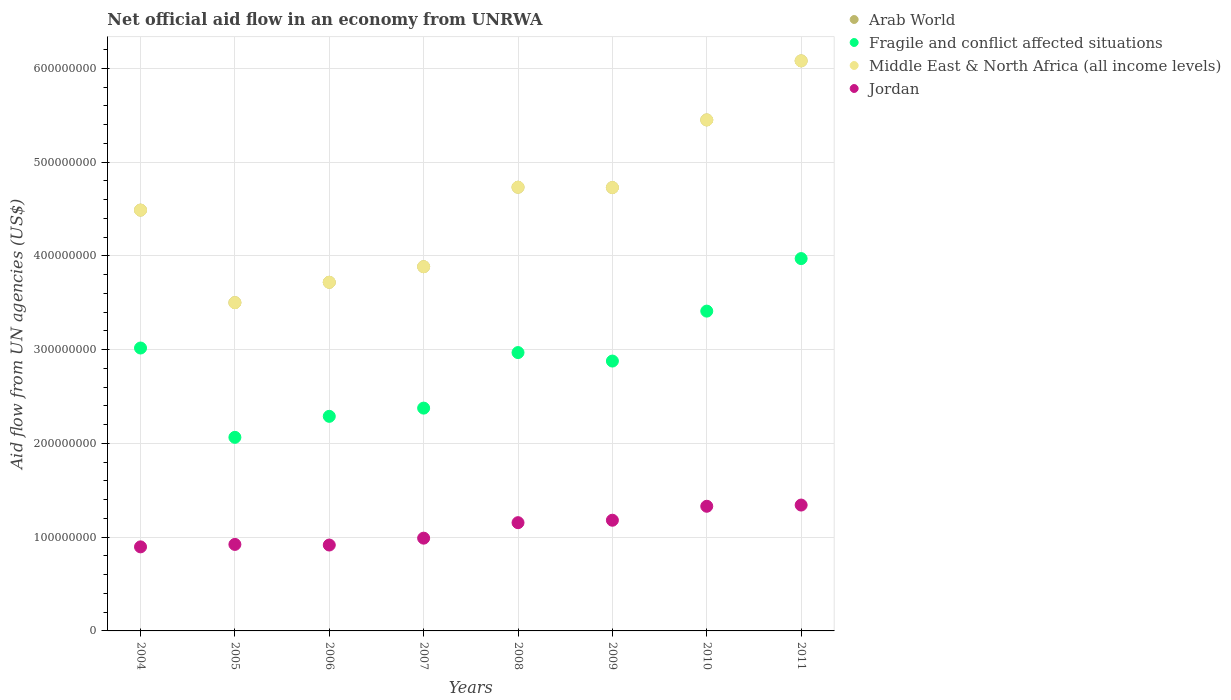Is the number of dotlines equal to the number of legend labels?
Provide a succinct answer. Yes. What is the net official aid flow in Fragile and conflict affected situations in 2005?
Ensure brevity in your answer.  2.06e+08. Across all years, what is the maximum net official aid flow in Jordan?
Your answer should be very brief. 1.34e+08. Across all years, what is the minimum net official aid flow in Arab World?
Make the answer very short. 3.50e+08. In which year was the net official aid flow in Arab World minimum?
Offer a very short reply. 2005. What is the total net official aid flow in Jordan in the graph?
Your response must be concise. 8.73e+08. What is the difference between the net official aid flow in Fragile and conflict affected situations in 2010 and that in 2011?
Your answer should be compact. -5.60e+07. What is the difference between the net official aid flow in Jordan in 2006 and the net official aid flow in Fragile and conflict affected situations in 2011?
Make the answer very short. -3.05e+08. What is the average net official aid flow in Middle East & North Africa (all income levels) per year?
Your answer should be very brief. 4.57e+08. In the year 2005, what is the difference between the net official aid flow in Fragile and conflict affected situations and net official aid flow in Middle East & North Africa (all income levels)?
Give a very brief answer. -1.44e+08. What is the ratio of the net official aid flow in Middle East & North Africa (all income levels) in 2005 to that in 2008?
Your response must be concise. 0.74. Is the net official aid flow in Middle East & North Africa (all income levels) in 2006 less than that in 2008?
Ensure brevity in your answer.  Yes. What is the difference between the highest and the second highest net official aid flow in Arab World?
Offer a terse response. 6.30e+07. What is the difference between the highest and the lowest net official aid flow in Middle East & North Africa (all income levels)?
Offer a terse response. 2.58e+08. In how many years, is the net official aid flow in Middle East & North Africa (all income levels) greater than the average net official aid flow in Middle East & North Africa (all income levels) taken over all years?
Your answer should be very brief. 4. Is it the case that in every year, the sum of the net official aid flow in Jordan and net official aid flow in Fragile and conflict affected situations  is greater than the net official aid flow in Middle East & North Africa (all income levels)?
Your response must be concise. No. Is the net official aid flow in Middle East & North Africa (all income levels) strictly less than the net official aid flow in Arab World over the years?
Your answer should be compact. No. What is the difference between two consecutive major ticks on the Y-axis?
Your answer should be very brief. 1.00e+08. Are the values on the major ticks of Y-axis written in scientific E-notation?
Provide a short and direct response. No. Does the graph contain grids?
Your answer should be compact. Yes. Where does the legend appear in the graph?
Offer a terse response. Top right. How are the legend labels stacked?
Your response must be concise. Vertical. What is the title of the graph?
Ensure brevity in your answer.  Net official aid flow in an economy from UNRWA. Does "Middle East & North Africa (developing only)" appear as one of the legend labels in the graph?
Provide a short and direct response. No. What is the label or title of the X-axis?
Offer a terse response. Years. What is the label or title of the Y-axis?
Make the answer very short. Aid flow from UN agencies (US$). What is the Aid flow from UN agencies (US$) in Arab World in 2004?
Keep it short and to the point. 4.49e+08. What is the Aid flow from UN agencies (US$) in Fragile and conflict affected situations in 2004?
Keep it short and to the point. 3.02e+08. What is the Aid flow from UN agencies (US$) of Middle East & North Africa (all income levels) in 2004?
Your answer should be compact. 4.49e+08. What is the Aid flow from UN agencies (US$) in Jordan in 2004?
Ensure brevity in your answer.  8.96e+07. What is the Aid flow from UN agencies (US$) in Arab World in 2005?
Offer a terse response. 3.50e+08. What is the Aid flow from UN agencies (US$) of Fragile and conflict affected situations in 2005?
Provide a short and direct response. 2.06e+08. What is the Aid flow from UN agencies (US$) of Middle East & North Africa (all income levels) in 2005?
Give a very brief answer. 3.50e+08. What is the Aid flow from UN agencies (US$) of Jordan in 2005?
Keep it short and to the point. 9.22e+07. What is the Aid flow from UN agencies (US$) of Arab World in 2006?
Your response must be concise. 3.72e+08. What is the Aid flow from UN agencies (US$) in Fragile and conflict affected situations in 2006?
Provide a succinct answer. 2.29e+08. What is the Aid flow from UN agencies (US$) in Middle East & North Africa (all income levels) in 2006?
Offer a very short reply. 3.72e+08. What is the Aid flow from UN agencies (US$) in Jordan in 2006?
Provide a short and direct response. 9.16e+07. What is the Aid flow from UN agencies (US$) of Arab World in 2007?
Provide a short and direct response. 3.88e+08. What is the Aid flow from UN agencies (US$) in Fragile and conflict affected situations in 2007?
Your answer should be very brief. 2.38e+08. What is the Aid flow from UN agencies (US$) of Middle East & North Africa (all income levels) in 2007?
Provide a short and direct response. 3.88e+08. What is the Aid flow from UN agencies (US$) in Jordan in 2007?
Keep it short and to the point. 9.89e+07. What is the Aid flow from UN agencies (US$) in Arab World in 2008?
Your answer should be very brief. 4.73e+08. What is the Aid flow from UN agencies (US$) in Fragile and conflict affected situations in 2008?
Give a very brief answer. 2.97e+08. What is the Aid flow from UN agencies (US$) in Middle East & North Africa (all income levels) in 2008?
Offer a terse response. 4.73e+08. What is the Aid flow from UN agencies (US$) of Jordan in 2008?
Your response must be concise. 1.15e+08. What is the Aid flow from UN agencies (US$) in Arab World in 2009?
Provide a short and direct response. 4.73e+08. What is the Aid flow from UN agencies (US$) in Fragile and conflict affected situations in 2009?
Keep it short and to the point. 2.88e+08. What is the Aid flow from UN agencies (US$) of Middle East & North Africa (all income levels) in 2009?
Keep it short and to the point. 4.73e+08. What is the Aid flow from UN agencies (US$) of Jordan in 2009?
Offer a terse response. 1.18e+08. What is the Aid flow from UN agencies (US$) of Arab World in 2010?
Provide a short and direct response. 5.45e+08. What is the Aid flow from UN agencies (US$) in Fragile and conflict affected situations in 2010?
Your response must be concise. 3.41e+08. What is the Aid flow from UN agencies (US$) in Middle East & North Africa (all income levels) in 2010?
Offer a terse response. 5.45e+08. What is the Aid flow from UN agencies (US$) of Jordan in 2010?
Your answer should be very brief. 1.33e+08. What is the Aid flow from UN agencies (US$) in Arab World in 2011?
Provide a succinct answer. 6.08e+08. What is the Aid flow from UN agencies (US$) in Fragile and conflict affected situations in 2011?
Provide a succinct answer. 3.97e+08. What is the Aid flow from UN agencies (US$) of Middle East & North Africa (all income levels) in 2011?
Ensure brevity in your answer.  6.08e+08. What is the Aid flow from UN agencies (US$) in Jordan in 2011?
Provide a succinct answer. 1.34e+08. Across all years, what is the maximum Aid flow from UN agencies (US$) in Arab World?
Your response must be concise. 6.08e+08. Across all years, what is the maximum Aid flow from UN agencies (US$) in Fragile and conflict affected situations?
Offer a very short reply. 3.97e+08. Across all years, what is the maximum Aid flow from UN agencies (US$) of Middle East & North Africa (all income levels)?
Give a very brief answer. 6.08e+08. Across all years, what is the maximum Aid flow from UN agencies (US$) of Jordan?
Provide a short and direct response. 1.34e+08. Across all years, what is the minimum Aid flow from UN agencies (US$) in Arab World?
Your response must be concise. 3.50e+08. Across all years, what is the minimum Aid flow from UN agencies (US$) of Fragile and conflict affected situations?
Give a very brief answer. 2.06e+08. Across all years, what is the minimum Aid flow from UN agencies (US$) in Middle East & North Africa (all income levels)?
Offer a very short reply. 3.50e+08. Across all years, what is the minimum Aid flow from UN agencies (US$) in Jordan?
Ensure brevity in your answer.  8.96e+07. What is the total Aid flow from UN agencies (US$) of Arab World in the graph?
Provide a short and direct response. 3.66e+09. What is the total Aid flow from UN agencies (US$) of Fragile and conflict affected situations in the graph?
Provide a succinct answer. 2.30e+09. What is the total Aid flow from UN agencies (US$) in Middle East & North Africa (all income levels) in the graph?
Provide a short and direct response. 3.66e+09. What is the total Aid flow from UN agencies (US$) in Jordan in the graph?
Your answer should be compact. 8.73e+08. What is the difference between the Aid flow from UN agencies (US$) of Arab World in 2004 and that in 2005?
Keep it short and to the point. 9.87e+07. What is the difference between the Aid flow from UN agencies (US$) in Fragile and conflict affected situations in 2004 and that in 2005?
Your answer should be very brief. 9.53e+07. What is the difference between the Aid flow from UN agencies (US$) of Middle East & North Africa (all income levels) in 2004 and that in 2005?
Offer a very short reply. 9.87e+07. What is the difference between the Aid flow from UN agencies (US$) of Jordan in 2004 and that in 2005?
Offer a terse response. -2.61e+06. What is the difference between the Aid flow from UN agencies (US$) of Arab World in 2004 and that in 2006?
Make the answer very short. 7.70e+07. What is the difference between the Aid flow from UN agencies (US$) in Fragile and conflict affected situations in 2004 and that in 2006?
Keep it short and to the point. 7.29e+07. What is the difference between the Aid flow from UN agencies (US$) of Middle East & North Africa (all income levels) in 2004 and that in 2006?
Your response must be concise. 7.70e+07. What is the difference between the Aid flow from UN agencies (US$) in Jordan in 2004 and that in 2006?
Make the answer very short. -1.96e+06. What is the difference between the Aid flow from UN agencies (US$) in Arab World in 2004 and that in 2007?
Offer a terse response. 6.03e+07. What is the difference between the Aid flow from UN agencies (US$) in Fragile and conflict affected situations in 2004 and that in 2007?
Your answer should be compact. 6.41e+07. What is the difference between the Aid flow from UN agencies (US$) in Middle East & North Africa (all income levels) in 2004 and that in 2007?
Provide a short and direct response. 6.03e+07. What is the difference between the Aid flow from UN agencies (US$) in Jordan in 2004 and that in 2007?
Ensure brevity in your answer.  -9.29e+06. What is the difference between the Aid flow from UN agencies (US$) in Arab World in 2004 and that in 2008?
Offer a very short reply. -2.44e+07. What is the difference between the Aid flow from UN agencies (US$) in Fragile and conflict affected situations in 2004 and that in 2008?
Give a very brief answer. 4.86e+06. What is the difference between the Aid flow from UN agencies (US$) in Middle East & North Africa (all income levels) in 2004 and that in 2008?
Your answer should be compact. -2.44e+07. What is the difference between the Aid flow from UN agencies (US$) in Jordan in 2004 and that in 2008?
Your response must be concise. -2.58e+07. What is the difference between the Aid flow from UN agencies (US$) in Arab World in 2004 and that in 2009?
Offer a terse response. -2.40e+07. What is the difference between the Aid flow from UN agencies (US$) of Fragile and conflict affected situations in 2004 and that in 2009?
Offer a terse response. 1.39e+07. What is the difference between the Aid flow from UN agencies (US$) of Middle East & North Africa (all income levels) in 2004 and that in 2009?
Give a very brief answer. -2.40e+07. What is the difference between the Aid flow from UN agencies (US$) in Jordan in 2004 and that in 2009?
Provide a succinct answer. -2.84e+07. What is the difference between the Aid flow from UN agencies (US$) of Arab World in 2004 and that in 2010?
Your answer should be very brief. -9.62e+07. What is the difference between the Aid flow from UN agencies (US$) of Fragile and conflict affected situations in 2004 and that in 2010?
Give a very brief answer. -3.94e+07. What is the difference between the Aid flow from UN agencies (US$) of Middle East & North Africa (all income levels) in 2004 and that in 2010?
Provide a short and direct response. -9.62e+07. What is the difference between the Aid flow from UN agencies (US$) in Jordan in 2004 and that in 2010?
Keep it short and to the point. -4.33e+07. What is the difference between the Aid flow from UN agencies (US$) of Arab World in 2004 and that in 2011?
Give a very brief answer. -1.59e+08. What is the difference between the Aid flow from UN agencies (US$) in Fragile and conflict affected situations in 2004 and that in 2011?
Provide a short and direct response. -9.54e+07. What is the difference between the Aid flow from UN agencies (US$) of Middle East & North Africa (all income levels) in 2004 and that in 2011?
Keep it short and to the point. -1.59e+08. What is the difference between the Aid flow from UN agencies (US$) of Jordan in 2004 and that in 2011?
Provide a short and direct response. -4.46e+07. What is the difference between the Aid flow from UN agencies (US$) in Arab World in 2005 and that in 2006?
Your answer should be compact. -2.17e+07. What is the difference between the Aid flow from UN agencies (US$) of Fragile and conflict affected situations in 2005 and that in 2006?
Provide a short and direct response. -2.24e+07. What is the difference between the Aid flow from UN agencies (US$) in Middle East & North Africa (all income levels) in 2005 and that in 2006?
Your answer should be compact. -2.17e+07. What is the difference between the Aid flow from UN agencies (US$) in Jordan in 2005 and that in 2006?
Provide a succinct answer. 6.50e+05. What is the difference between the Aid flow from UN agencies (US$) of Arab World in 2005 and that in 2007?
Offer a terse response. -3.83e+07. What is the difference between the Aid flow from UN agencies (US$) in Fragile and conflict affected situations in 2005 and that in 2007?
Your answer should be very brief. -3.12e+07. What is the difference between the Aid flow from UN agencies (US$) of Middle East & North Africa (all income levels) in 2005 and that in 2007?
Offer a terse response. -3.83e+07. What is the difference between the Aid flow from UN agencies (US$) of Jordan in 2005 and that in 2007?
Your response must be concise. -6.68e+06. What is the difference between the Aid flow from UN agencies (US$) in Arab World in 2005 and that in 2008?
Provide a short and direct response. -1.23e+08. What is the difference between the Aid flow from UN agencies (US$) of Fragile and conflict affected situations in 2005 and that in 2008?
Make the answer very short. -9.04e+07. What is the difference between the Aid flow from UN agencies (US$) of Middle East & North Africa (all income levels) in 2005 and that in 2008?
Offer a terse response. -1.23e+08. What is the difference between the Aid flow from UN agencies (US$) of Jordan in 2005 and that in 2008?
Your answer should be compact. -2.32e+07. What is the difference between the Aid flow from UN agencies (US$) of Arab World in 2005 and that in 2009?
Your response must be concise. -1.23e+08. What is the difference between the Aid flow from UN agencies (US$) in Fragile and conflict affected situations in 2005 and that in 2009?
Provide a short and direct response. -8.14e+07. What is the difference between the Aid flow from UN agencies (US$) in Middle East & North Africa (all income levels) in 2005 and that in 2009?
Your answer should be compact. -1.23e+08. What is the difference between the Aid flow from UN agencies (US$) in Jordan in 2005 and that in 2009?
Offer a terse response. -2.58e+07. What is the difference between the Aid flow from UN agencies (US$) of Arab World in 2005 and that in 2010?
Give a very brief answer. -1.95e+08. What is the difference between the Aid flow from UN agencies (US$) of Fragile and conflict affected situations in 2005 and that in 2010?
Keep it short and to the point. -1.35e+08. What is the difference between the Aid flow from UN agencies (US$) in Middle East & North Africa (all income levels) in 2005 and that in 2010?
Your answer should be very brief. -1.95e+08. What is the difference between the Aid flow from UN agencies (US$) in Jordan in 2005 and that in 2010?
Give a very brief answer. -4.07e+07. What is the difference between the Aid flow from UN agencies (US$) in Arab World in 2005 and that in 2011?
Your answer should be very brief. -2.58e+08. What is the difference between the Aid flow from UN agencies (US$) in Fragile and conflict affected situations in 2005 and that in 2011?
Your response must be concise. -1.91e+08. What is the difference between the Aid flow from UN agencies (US$) in Middle East & North Africa (all income levels) in 2005 and that in 2011?
Provide a short and direct response. -2.58e+08. What is the difference between the Aid flow from UN agencies (US$) in Jordan in 2005 and that in 2011?
Your answer should be very brief. -4.20e+07. What is the difference between the Aid flow from UN agencies (US$) in Arab World in 2006 and that in 2007?
Offer a very short reply. -1.66e+07. What is the difference between the Aid flow from UN agencies (US$) of Fragile and conflict affected situations in 2006 and that in 2007?
Ensure brevity in your answer.  -8.77e+06. What is the difference between the Aid flow from UN agencies (US$) of Middle East & North Africa (all income levels) in 2006 and that in 2007?
Offer a terse response. -1.66e+07. What is the difference between the Aid flow from UN agencies (US$) in Jordan in 2006 and that in 2007?
Offer a terse response. -7.33e+06. What is the difference between the Aid flow from UN agencies (US$) in Arab World in 2006 and that in 2008?
Provide a short and direct response. -1.01e+08. What is the difference between the Aid flow from UN agencies (US$) in Fragile and conflict affected situations in 2006 and that in 2008?
Ensure brevity in your answer.  -6.80e+07. What is the difference between the Aid flow from UN agencies (US$) in Middle East & North Africa (all income levels) in 2006 and that in 2008?
Give a very brief answer. -1.01e+08. What is the difference between the Aid flow from UN agencies (US$) of Jordan in 2006 and that in 2008?
Provide a succinct answer. -2.38e+07. What is the difference between the Aid flow from UN agencies (US$) of Arab World in 2006 and that in 2009?
Your answer should be compact. -1.01e+08. What is the difference between the Aid flow from UN agencies (US$) in Fragile and conflict affected situations in 2006 and that in 2009?
Your response must be concise. -5.90e+07. What is the difference between the Aid flow from UN agencies (US$) in Middle East & North Africa (all income levels) in 2006 and that in 2009?
Your response must be concise. -1.01e+08. What is the difference between the Aid flow from UN agencies (US$) of Jordan in 2006 and that in 2009?
Give a very brief answer. -2.64e+07. What is the difference between the Aid flow from UN agencies (US$) of Arab World in 2006 and that in 2010?
Your answer should be compact. -1.73e+08. What is the difference between the Aid flow from UN agencies (US$) of Fragile and conflict affected situations in 2006 and that in 2010?
Your answer should be compact. -1.12e+08. What is the difference between the Aid flow from UN agencies (US$) in Middle East & North Africa (all income levels) in 2006 and that in 2010?
Keep it short and to the point. -1.73e+08. What is the difference between the Aid flow from UN agencies (US$) in Jordan in 2006 and that in 2010?
Offer a very short reply. -4.13e+07. What is the difference between the Aid flow from UN agencies (US$) in Arab World in 2006 and that in 2011?
Give a very brief answer. -2.36e+08. What is the difference between the Aid flow from UN agencies (US$) in Fragile and conflict affected situations in 2006 and that in 2011?
Your response must be concise. -1.68e+08. What is the difference between the Aid flow from UN agencies (US$) of Middle East & North Africa (all income levels) in 2006 and that in 2011?
Your response must be concise. -2.36e+08. What is the difference between the Aid flow from UN agencies (US$) in Jordan in 2006 and that in 2011?
Provide a succinct answer. -4.26e+07. What is the difference between the Aid flow from UN agencies (US$) of Arab World in 2007 and that in 2008?
Ensure brevity in your answer.  -8.48e+07. What is the difference between the Aid flow from UN agencies (US$) of Fragile and conflict affected situations in 2007 and that in 2008?
Offer a very short reply. -5.92e+07. What is the difference between the Aid flow from UN agencies (US$) in Middle East & North Africa (all income levels) in 2007 and that in 2008?
Ensure brevity in your answer.  -8.48e+07. What is the difference between the Aid flow from UN agencies (US$) in Jordan in 2007 and that in 2008?
Keep it short and to the point. -1.65e+07. What is the difference between the Aid flow from UN agencies (US$) in Arab World in 2007 and that in 2009?
Your answer should be compact. -8.44e+07. What is the difference between the Aid flow from UN agencies (US$) in Fragile and conflict affected situations in 2007 and that in 2009?
Your response must be concise. -5.02e+07. What is the difference between the Aid flow from UN agencies (US$) of Middle East & North Africa (all income levels) in 2007 and that in 2009?
Make the answer very short. -8.44e+07. What is the difference between the Aid flow from UN agencies (US$) of Jordan in 2007 and that in 2009?
Give a very brief answer. -1.91e+07. What is the difference between the Aid flow from UN agencies (US$) of Arab World in 2007 and that in 2010?
Provide a succinct answer. -1.57e+08. What is the difference between the Aid flow from UN agencies (US$) of Fragile and conflict affected situations in 2007 and that in 2010?
Your response must be concise. -1.03e+08. What is the difference between the Aid flow from UN agencies (US$) of Middle East & North Africa (all income levels) in 2007 and that in 2010?
Make the answer very short. -1.57e+08. What is the difference between the Aid flow from UN agencies (US$) of Jordan in 2007 and that in 2010?
Keep it short and to the point. -3.40e+07. What is the difference between the Aid flow from UN agencies (US$) in Arab World in 2007 and that in 2011?
Provide a succinct answer. -2.20e+08. What is the difference between the Aid flow from UN agencies (US$) in Fragile and conflict affected situations in 2007 and that in 2011?
Make the answer very short. -1.59e+08. What is the difference between the Aid flow from UN agencies (US$) of Middle East & North Africa (all income levels) in 2007 and that in 2011?
Your answer should be very brief. -2.20e+08. What is the difference between the Aid flow from UN agencies (US$) in Jordan in 2007 and that in 2011?
Keep it short and to the point. -3.53e+07. What is the difference between the Aid flow from UN agencies (US$) of Arab World in 2008 and that in 2009?
Keep it short and to the point. 3.60e+05. What is the difference between the Aid flow from UN agencies (US$) of Fragile and conflict affected situations in 2008 and that in 2009?
Ensure brevity in your answer.  9.05e+06. What is the difference between the Aid flow from UN agencies (US$) in Jordan in 2008 and that in 2009?
Keep it short and to the point. -2.61e+06. What is the difference between the Aid flow from UN agencies (US$) in Arab World in 2008 and that in 2010?
Make the answer very short. -7.18e+07. What is the difference between the Aid flow from UN agencies (US$) of Fragile and conflict affected situations in 2008 and that in 2010?
Offer a terse response. -4.42e+07. What is the difference between the Aid flow from UN agencies (US$) of Middle East & North Africa (all income levels) in 2008 and that in 2010?
Give a very brief answer. -7.18e+07. What is the difference between the Aid flow from UN agencies (US$) of Jordan in 2008 and that in 2010?
Your answer should be compact. -1.75e+07. What is the difference between the Aid flow from UN agencies (US$) of Arab World in 2008 and that in 2011?
Offer a terse response. -1.35e+08. What is the difference between the Aid flow from UN agencies (US$) in Fragile and conflict affected situations in 2008 and that in 2011?
Make the answer very short. -1.00e+08. What is the difference between the Aid flow from UN agencies (US$) of Middle East & North Africa (all income levels) in 2008 and that in 2011?
Keep it short and to the point. -1.35e+08. What is the difference between the Aid flow from UN agencies (US$) of Jordan in 2008 and that in 2011?
Make the answer very short. -1.88e+07. What is the difference between the Aid flow from UN agencies (US$) of Arab World in 2009 and that in 2010?
Make the answer very short. -7.21e+07. What is the difference between the Aid flow from UN agencies (US$) of Fragile and conflict affected situations in 2009 and that in 2010?
Provide a succinct answer. -5.33e+07. What is the difference between the Aid flow from UN agencies (US$) of Middle East & North Africa (all income levels) in 2009 and that in 2010?
Offer a very short reply. -7.21e+07. What is the difference between the Aid flow from UN agencies (US$) in Jordan in 2009 and that in 2010?
Keep it short and to the point. -1.49e+07. What is the difference between the Aid flow from UN agencies (US$) of Arab World in 2009 and that in 2011?
Your answer should be compact. -1.35e+08. What is the difference between the Aid flow from UN agencies (US$) of Fragile and conflict affected situations in 2009 and that in 2011?
Your answer should be very brief. -1.09e+08. What is the difference between the Aid flow from UN agencies (US$) of Middle East & North Africa (all income levels) in 2009 and that in 2011?
Offer a very short reply. -1.35e+08. What is the difference between the Aid flow from UN agencies (US$) of Jordan in 2009 and that in 2011?
Offer a very short reply. -1.62e+07. What is the difference between the Aid flow from UN agencies (US$) of Arab World in 2010 and that in 2011?
Offer a terse response. -6.30e+07. What is the difference between the Aid flow from UN agencies (US$) in Fragile and conflict affected situations in 2010 and that in 2011?
Your answer should be compact. -5.60e+07. What is the difference between the Aid flow from UN agencies (US$) of Middle East & North Africa (all income levels) in 2010 and that in 2011?
Provide a succinct answer. -6.30e+07. What is the difference between the Aid flow from UN agencies (US$) of Jordan in 2010 and that in 2011?
Offer a very short reply. -1.29e+06. What is the difference between the Aid flow from UN agencies (US$) in Arab World in 2004 and the Aid flow from UN agencies (US$) in Fragile and conflict affected situations in 2005?
Ensure brevity in your answer.  2.42e+08. What is the difference between the Aid flow from UN agencies (US$) in Arab World in 2004 and the Aid flow from UN agencies (US$) in Middle East & North Africa (all income levels) in 2005?
Your answer should be very brief. 9.87e+07. What is the difference between the Aid flow from UN agencies (US$) in Arab World in 2004 and the Aid flow from UN agencies (US$) in Jordan in 2005?
Ensure brevity in your answer.  3.57e+08. What is the difference between the Aid flow from UN agencies (US$) in Fragile and conflict affected situations in 2004 and the Aid flow from UN agencies (US$) in Middle East & North Africa (all income levels) in 2005?
Offer a terse response. -4.84e+07. What is the difference between the Aid flow from UN agencies (US$) of Fragile and conflict affected situations in 2004 and the Aid flow from UN agencies (US$) of Jordan in 2005?
Your answer should be very brief. 2.09e+08. What is the difference between the Aid flow from UN agencies (US$) in Middle East & North Africa (all income levels) in 2004 and the Aid flow from UN agencies (US$) in Jordan in 2005?
Your answer should be compact. 3.57e+08. What is the difference between the Aid flow from UN agencies (US$) in Arab World in 2004 and the Aid flow from UN agencies (US$) in Fragile and conflict affected situations in 2006?
Give a very brief answer. 2.20e+08. What is the difference between the Aid flow from UN agencies (US$) in Arab World in 2004 and the Aid flow from UN agencies (US$) in Middle East & North Africa (all income levels) in 2006?
Your answer should be very brief. 7.70e+07. What is the difference between the Aid flow from UN agencies (US$) of Arab World in 2004 and the Aid flow from UN agencies (US$) of Jordan in 2006?
Your answer should be very brief. 3.57e+08. What is the difference between the Aid flow from UN agencies (US$) of Fragile and conflict affected situations in 2004 and the Aid flow from UN agencies (US$) of Middle East & North Africa (all income levels) in 2006?
Ensure brevity in your answer.  -7.01e+07. What is the difference between the Aid flow from UN agencies (US$) of Fragile and conflict affected situations in 2004 and the Aid flow from UN agencies (US$) of Jordan in 2006?
Provide a short and direct response. 2.10e+08. What is the difference between the Aid flow from UN agencies (US$) in Middle East & North Africa (all income levels) in 2004 and the Aid flow from UN agencies (US$) in Jordan in 2006?
Provide a short and direct response. 3.57e+08. What is the difference between the Aid flow from UN agencies (US$) in Arab World in 2004 and the Aid flow from UN agencies (US$) in Fragile and conflict affected situations in 2007?
Your response must be concise. 2.11e+08. What is the difference between the Aid flow from UN agencies (US$) in Arab World in 2004 and the Aid flow from UN agencies (US$) in Middle East & North Africa (all income levels) in 2007?
Your answer should be very brief. 6.03e+07. What is the difference between the Aid flow from UN agencies (US$) of Arab World in 2004 and the Aid flow from UN agencies (US$) of Jordan in 2007?
Provide a short and direct response. 3.50e+08. What is the difference between the Aid flow from UN agencies (US$) of Fragile and conflict affected situations in 2004 and the Aid flow from UN agencies (US$) of Middle East & North Africa (all income levels) in 2007?
Your response must be concise. -8.67e+07. What is the difference between the Aid flow from UN agencies (US$) in Fragile and conflict affected situations in 2004 and the Aid flow from UN agencies (US$) in Jordan in 2007?
Ensure brevity in your answer.  2.03e+08. What is the difference between the Aid flow from UN agencies (US$) in Middle East & North Africa (all income levels) in 2004 and the Aid flow from UN agencies (US$) in Jordan in 2007?
Provide a short and direct response. 3.50e+08. What is the difference between the Aid flow from UN agencies (US$) in Arab World in 2004 and the Aid flow from UN agencies (US$) in Fragile and conflict affected situations in 2008?
Offer a terse response. 1.52e+08. What is the difference between the Aid flow from UN agencies (US$) of Arab World in 2004 and the Aid flow from UN agencies (US$) of Middle East & North Africa (all income levels) in 2008?
Provide a succinct answer. -2.44e+07. What is the difference between the Aid flow from UN agencies (US$) of Arab World in 2004 and the Aid flow from UN agencies (US$) of Jordan in 2008?
Your response must be concise. 3.33e+08. What is the difference between the Aid flow from UN agencies (US$) of Fragile and conflict affected situations in 2004 and the Aid flow from UN agencies (US$) of Middle East & North Africa (all income levels) in 2008?
Make the answer very short. -1.71e+08. What is the difference between the Aid flow from UN agencies (US$) of Fragile and conflict affected situations in 2004 and the Aid flow from UN agencies (US$) of Jordan in 2008?
Keep it short and to the point. 1.86e+08. What is the difference between the Aid flow from UN agencies (US$) of Middle East & North Africa (all income levels) in 2004 and the Aid flow from UN agencies (US$) of Jordan in 2008?
Offer a very short reply. 3.33e+08. What is the difference between the Aid flow from UN agencies (US$) of Arab World in 2004 and the Aid flow from UN agencies (US$) of Fragile and conflict affected situations in 2009?
Offer a very short reply. 1.61e+08. What is the difference between the Aid flow from UN agencies (US$) in Arab World in 2004 and the Aid flow from UN agencies (US$) in Middle East & North Africa (all income levels) in 2009?
Your answer should be very brief. -2.40e+07. What is the difference between the Aid flow from UN agencies (US$) of Arab World in 2004 and the Aid flow from UN agencies (US$) of Jordan in 2009?
Your response must be concise. 3.31e+08. What is the difference between the Aid flow from UN agencies (US$) in Fragile and conflict affected situations in 2004 and the Aid flow from UN agencies (US$) in Middle East & North Africa (all income levels) in 2009?
Provide a short and direct response. -1.71e+08. What is the difference between the Aid flow from UN agencies (US$) of Fragile and conflict affected situations in 2004 and the Aid flow from UN agencies (US$) of Jordan in 2009?
Offer a terse response. 1.84e+08. What is the difference between the Aid flow from UN agencies (US$) in Middle East & North Africa (all income levels) in 2004 and the Aid flow from UN agencies (US$) in Jordan in 2009?
Keep it short and to the point. 3.31e+08. What is the difference between the Aid flow from UN agencies (US$) of Arab World in 2004 and the Aid flow from UN agencies (US$) of Fragile and conflict affected situations in 2010?
Give a very brief answer. 1.08e+08. What is the difference between the Aid flow from UN agencies (US$) of Arab World in 2004 and the Aid flow from UN agencies (US$) of Middle East & North Africa (all income levels) in 2010?
Your answer should be compact. -9.62e+07. What is the difference between the Aid flow from UN agencies (US$) in Arab World in 2004 and the Aid flow from UN agencies (US$) in Jordan in 2010?
Provide a succinct answer. 3.16e+08. What is the difference between the Aid flow from UN agencies (US$) of Fragile and conflict affected situations in 2004 and the Aid flow from UN agencies (US$) of Middle East & North Africa (all income levels) in 2010?
Ensure brevity in your answer.  -2.43e+08. What is the difference between the Aid flow from UN agencies (US$) in Fragile and conflict affected situations in 2004 and the Aid flow from UN agencies (US$) in Jordan in 2010?
Offer a very short reply. 1.69e+08. What is the difference between the Aid flow from UN agencies (US$) of Middle East & North Africa (all income levels) in 2004 and the Aid flow from UN agencies (US$) of Jordan in 2010?
Keep it short and to the point. 3.16e+08. What is the difference between the Aid flow from UN agencies (US$) in Arab World in 2004 and the Aid flow from UN agencies (US$) in Fragile and conflict affected situations in 2011?
Make the answer very short. 5.17e+07. What is the difference between the Aid flow from UN agencies (US$) in Arab World in 2004 and the Aid flow from UN agencies (US$) in Middle East & North Africa (all income levels) in 2011?
Your answer should be compact. -1.59e+08. What is the difference between the Aid flow from UN agencies (US$) in Arab World in 2004 and the Aid flow from UN agencies (US$) in Jordan in 2011?
Provide a succinct answer. 3.15e+08. What is the difference between the Aid flow from UN agencies (US$) of Fragile and conflict affected situations in 2004 and the Aid flow from UN agencies (US$) of Middle East & North Africa (all income levels) in 2011?
Offer a terse response. -3.06e+08. What is the difference between the Aid flow from UN agencies (US$) of Fragile and conflict affected situations in 2004 and the Aid flow from UN agencies (US$) of Jordan in 2011?
Your response must be concise. 1.67e+08. What is the difference between the Aid flow from UN agencies (US$) of Middle East & North Africa (all income levels) in 2004 and the Aid flow from UN agencies (US$) of Jordan in 2011?
Your answer should be very brief. 3.15e+08. What is the difference between the Aid flow from UN agencies (US$) in Arab World in 2005 and the Aid flow from UN agencies (US$) in Fragile and conflict affected situations in 2006?
Your response must be concise. 1.21e+08. What is the difference between the Aid flow from UN agencies (US$) in Arab World in 2005 and the Aid flow from UN agencies (US$) in Middle East & North Africa (all income levels) in 2006?
Offer a terse response. -2.17e+07. What is the difference between the Aid flow from UN agencies (US$) of Arab World in 2005 and the Aid flow from UN agencies (US$) of Jordan in 2006?
Your response must be concise. 2.59e+08. What is the difference between the Aid flow from UN agencies (US$) in Fragile and conflict affected situations in 2005 and the Aid flow from UN agencies (US$) in Middle East & North Africa (all income levels) in 2006?
Make the answer very short. -1.65e+08. What is the difference between the Aid flow from UN agencies (US$) in Fragile and conflict affected situations in 2005 and the Aid flow from UN agencies (US$) in Jordan in 2006?
Offer a very short reply. 1.15e+08. What is the difference between the Aid flow from UN agencies (US$) of Middle East & North Africa (all income levels) in 2005 and the Aid flow from UN agencies (US$) of Jordan in 2006?
Your response must be concise. 2.59e+08. What is the difference between the Aid flow from UN agencies (US$) in Arab World in 2005 and the Aid flow from UN agencies (US$) in Fragile and conflict affected situations in 2007?
Provide a short and direct response. 1.12e+08. What is the difference between the Aid flow from UN agencies (US$) of Arab World in 2005 and the Aid flow from UN agencies (US$) of Middle East & North Africa (all income levels) in 2007?
Your answer should be compact. -3.83e+07. What is the difference between the Aid flow from UN agencies (US$) in Arab World in 2005 and the Aid flow from UN agencies (US$) in Jordan in 2007?
Provide a succinct answer. 2.51e+08. What is the difference between the Aid flow from UN agencies (US$) of Fragile and conflict affected situations in 2005 and the Aid flow from UN agencies (US$) of Middle East & North Africa (all income levels) in 2007?
Your response must be concise. -1.82e+08. What is the difference between the Aid flow from UN agencies (US$) of Fragile and conflict affected situations in 2005 and the Aid flow from UN agencies (US$) of Jordan in 2007?
Provide a short and direct response. 1.08e+08. What is the difference between the Aid flow from UN agencies (US$) in Middle East & North Africa (all income levels) in 2005 and the Aid flow from UN agencies (US$) in Jordan in 2007?
Make the answer very short. 2.51e+08. What is the difference between the Aid flow from UN agencies (US$) of Arab World in 2005 and the Aid flow from UN agencies (US$) of Fragile and conflict affected situations in 2008?
Offer a terse response. 5.33e+07. What is the difference between the Aid flow from UN agencies (US$) in Arab World in 2005 and the Aid flow from UN agencies (US$) in Middle East & North Africa (all income levels) in 2008?
Your response must be concise. -1.23e+08. What is the difference between the Aid flow from UN agencies (US$) of Arab World in 2005 and the Aid flow from UN agencies (US$) of Jordan in 2008?
Ensure brevity in your answer.  2.35e+08. What is the difference between the Aid flow from UN agencies (US$) of Fragile and conflict affected situations in 2005 and the Aid flow from UN agencies (US$) of Middle East & North Africa (all income levels) in 2008?
Your answer should be compact. -2.67e+08. What is the difference between the Aid flow from UN agencies (US$) in Fragile and conflict affected situations in 2005 and the Aid flow from UN agencies (US$) in Jordan in 2008?
Keep it short and to the point. 9.10e+07. What is the difference between the Aid flow from UN agencies (US$) in Middle East & North Africa (all income levels) in 2005 and the Aid flow from UN agencies (US$) in Jordan in 2008?
Provide a short and direct response. 2.35e+08. What is the difference between the Aid flow from UN agencies (US$) in Arab World in 2005 and the Aid flow from UN agencies (US$) in Fragile and conflict affected situations in 2009?
Your response must be concise. 6.23e+07. What is the difference between the Aid flow from UN agencies (US$) of Arab World in 2005 and the Aid flow from UN agencies (US$) of Middle East & North Africa (all income levels) in 2009?
Offer a terse response. -1.23e+08. What is the difference between the Aid flow from UN agencies (US$) in Arab World in 2005 and the Aid flow from UN agencies (US$) in Jordan in 2009?
Your answer should be compact. 2.32e+08. What is the difference between the Aid flow from UN agencies (US$) in Fragile and conflict affected situations in 2005 and the Aid flow from UN agencies (US$) in Middle East & North Africa (all income levels) in 2009?
Provide a succinct answer. -2.66e+08. What is the difference between the Aid flow from UN agencies (US$) of Fragile and conflict affected situations in 2005 and the Aid flow from UN agencies (US$) of Jordan in 2009?
Your answer should be very brief. 8.84e+07. What is the difference between the Aid flow from UN agencies (US$) in Middle East & North Africa (all income levels) in 2005 and the Aid flow from UN agencies (US$) in Jordan in 2009?
Offer a very short reply. 2.32e+08. What is the difference between the Aid flow from UN agencies (US$) in Arab World in 2005 and the Aid flow from UN agencies (US$) in Fragile and conflict affected situations in 2010?
Your answer should be compact. 9.05e+06. What is the difference between the Aid flow from UN agencies (US$) in Arab World in 2005 and the Aid flow from UN agencies (US$) in Middle East & North Africa (all income levels) in 2010?
Your answer should be very brief. -1.95e+08. What is the difference between the Aid flow from UN agencies (US$) of Arab World in 2005 and the Aid flow from UN agencies (US$) of Jordan in 2010?
Provide a succinct answer. 2.17e+08. What is the difference between the Aid flow from UN agencies (US$) of Fragile and conflict affected situations in 2005 and the Aid flow from UN agencies (US$) of Middle East & North Africa (all income levels) in 2010?
Offer a terse response. -3.39e+08. What is the difference between the Aid flow from UN agencies (US$) in Fragile and conflict affected situations in 2005 and the Aid flow from UN agencies (US$) in Jordan in 2010?
Your answer should be very brief. 7.35e+07. What is the difference between the Aid flow from UN agencies (US$) in Middle East & North Africa (all income levels) in 2005 and the Aid flow from UN agencies (US$) in Jordan in 2010?
Provide a succinct answer. 2.17e+08. What is the difference between the Aid flow from UN agencies (US$) of Arab World in 2005 and the Aid flow from UN agencies (US$) of Fragile and conflict affected situations in 2011?
Provide a succinct answer. -4.70e+07. What is the difference between the Aid flow from UN agencies (US$) in Arab World in 2005 and the Aid flow from UN agencies (US$) in Middle East & North Africa (all income levels) in 2011?
Your answer should be compact. -2.58e+08. What is the difference between the Aid flow from UN agencies (US$) of Arab World in 2005 and the Aid flow from UN agencies (US$) of Jordan in 2011?
Give a very brief answer. 2.16e+08. What is the difference between the Aid flow from UN agencies (US$) of Fragile and conflict affected situations in 2005 and the Aid flow from UN agencies (US$) of Middle East & North Africa (all income levels) in 2011?
Make the answer very short. -4.02e+08. What is the difference between the Aid flow from UN agencies (US$) of Fragile and conflict affected situations in 2005 and the Aid flow from UN agencies (US$) of Jordan in 2011?
Your answer should be very brief. 7.22e+07. What is the difference between the Aid flow from UN agencies (US$) in Middle East & North Africa (all income levels) in 2005 and the Aid flow from UN agencies (US$) in Jordan in 2011?
Offer a terse response. 2.16e+08. What is the difference between the Aid flow from UN agencies (US$) in Arab World in 2006 and the Aid flow from UN agencies (US$) in Fragile and conflict affected situations in 2007?
Make the answer very short. 1.34e+08. What is the difference between the Aid flow from UN agencies (US$) in Arab World in 2006 and the Aid flow from UN agencies (US$) in Middle East & North Africa (all income levels) in 2007?
Make the answer very short. -1.66e+07. What is the difference between the Aid flow from UN agencies (US$) of Arab World in 2006 and the Aid flow from UN agencies (US$) of Jordan in 2007?
Provide a short and direct response. 2.73e+08. What is the difference between the Aid flow from UN agencies (US$) of Fragile and conflict affected situations in 2006 and the Aid flow from UN agencies (US$) of Middle East & North Africa (all income levels) in 2007?
Offer a terse response. -1.60e+08. What is the difference between the Aid flow from UN agencies (US$) in Fragile and conflict affected situations in 2006 and the Aid flow from UN agencies (US$) in Jordan in 2007?
Your answer should be compact. 1.30e+08. What is the difference between the Aid flow from UN agencies (US$) of Middle East & North Africa (all income levels) in 2006 and the Aid flow from UN agencies (US$) of Jordan in 2007?
Your answer should be very brief. 2.73e+08. What is the difference between the Aid flow from UN agencies (US$) of Arab World in 2006 and the Aid flow from UN agencies (US$) of Fragile and conflict affected situations in 2008?
Offer a terse response. 7.50e+07. What is the difference between the Aid flow from UN agencies (US$) of Arab World in 2006 and the Aid flow from UN agencies (US$) of Middle East & North Africa (all income levels) in 2008?
Your response must be concise. -1.01e+08. What is the difference between the Aid flow from UN agencies (US$) in Arab World in 2006 and the Aid flow from UN agencies (US$) in Jordan in 2008?
Provide a short and direct response. 2.56e+08. What is the difference between the Aid flow from UN agencies (US$) of Fragile and conflict affected situations in 2006 and the Aid flow from UN agencies (US$) of Middle East & North Africa (all income levels) in 2008?
Make the answer very short. -2.44e+08. What is the difference between the Aid flow from UN agencies (US$) of Fragile and conflict affected situations in 2006 and the Aid flow from UN agencies (US$) of Jordan in 2008?
Keep it short and to the point. 1.13e+08. What is the difference between the Aid flow from UN agencies (US$) of Middle East & North Africa (all income levels) in 2006 and the Aid flow from UN agencies (US$) of Jordan in 2008?
Your answer should be compact. 2.56e+08. What is the difference between the Aid flow from UN agencies (US$) in Arab World in 2006 and the Aid flow from UN agencies (US$) in Fragile and conflict affected situations in 2009?
Your response must be concise. 8.40e+07. What is the difference between the Aid flow from UN agencies (US$) in Arab World in 2006 and the Aid flow from UN agencies (US$) in Middle East & North Africa (all income levels) in 2009?
Your response must be concise. -1.01e+08. What is the difference between the Aid flow from UN agencies (US$) of Arab World in 2006 and the Aid flow from UN agencies (US$) of Jordan in 2009?
Offer a very short reply. 2.54e+08. What is the difference between the Aid flow from UN agencies (US$) of Fragile and conflict affected situations in 2006 and the Aid flow from UN agencies (US$) of Middle East & North Africa (all income levels) in 2009?
Keep it short and to the point. -2.44e+08. What is the difference between the Aid flow from UN agencies (US$) in Fragile and conflict affected situations in 2006 and the Aid flow from UN agencies (US$) in Jordan in 2009?
Give a very brief answer. 1.11e+08. What is the difference between the Aid flow from UN agencies (US$) of Middle East & North Africa (all income levels) in 2006 and the Aid flow from UN agencies (US$) of Jordan in 2009?
Your answer should be compact. 2.54e+08. What is the difference between the Aid flow from UN agencies (US$) of Arab World in 2006 and the Aid flow from UN agencies (US$) of Fragile and conflict affected situations in 2010?
Ensure brevity in your answer.  3.08e+07. What is the difference between the Aid flow from UN agencies (US$) in Arab World in 2006 and the Aid flow from UN agencies (US$) in Middle East & North Africa (all income levels) in 2010?
Keep it short and to the point. -1.73e+08. What is the difference between the Aid flow from UN agencies (US$) of Arab World in 2006 and the Aid flow from UN agencies (US$) of Jordan in 2010?
Offer a very short reply. 2.39e+08. What is the difference between the Aid flow from UN agencies (US$) of Fragile and conflict affected situations in 2006 and the Aid flow from UN agencies (US$) of Middle East & North Africa (all income levels) in 2010?
Make the answer very short. -3.16e+08. What is the difference between the Aid flow from UN agencies (US$) of Fragile and conflict affected situations in 2006 and the Aid flow from UN agencies (US$) of Jordan in 2010?
Make the answer very short. 9.59e+07. What is the difference between the Aid flow from UN agencies (US$) in Middle East & North Africa (all income levels) in 2006 and the Aid flow from UN agencies (US$) in Jordan in 2010?
Ensure brevity in your answer.  2.39e+08. What is the difference between the Aid flow from UN agencies (US$) in Arab World in 2006 and the Aid flow from UN agencies (US$) in Fragile and conflict affected situations in 2011?
Make the answer very short. -2.53e+07. What is the difference between the Aid flow from UN agencies (US$) of Arab World in 2006 and the Aid flow from UN agencies (US$) of Middle East & North Africa (all income levels) in 2011?
Your answer should be compact. -2.36e+08. What is the difference between the Aid flow from UN agencies (US$) in Arab World in 2006 and the Aid flow from UN agencies (US$) in Jordan in 2011?
Make the answer very short. 2.38e+08. What is the difference between the Aid flow from UN agencies (US$) of Fragile and conflict affected situations in 2006 and the Aid flow from UN agencies (US$) of Middle East & North Africa (all income levels) in 2011?
Offer a very short reply. -3.79e+08. What is the difference between the Aid flow from UN agencies (US$) of Fragile and conflict affected situations in 2006 and the Aid flow from UN agencies (US$) of Jordan in 2011?
Your response must be concise. 9.46e+07. What is the difference between the Aid flow from UN agencies (US$) in Middle East & North Africa (all income levels) in 2006 and the Aid flow from UN agencies (US$) in Jordan in 2011?
Offer a terse response. 2.38e+08. What is the difference between the Aid flow from UN agencies (US$) of Arab World in 2007 and the Aid flow from UN agencies (US$) of Fragile and conflict affected situations in 2008?
Your response must be concise. 9.16e+07. What is the difference between the Aid flow from UN agencies (US$) of Arab World in 2007 and the Aid flow from UN agencies (US$) of Middle East & North Africa (all income levels) in 2008?
Keep it short and to the point. -8.48e+07. What is the difference between the Aid flow from UN agencies (US$) of Arab World in 2007 and the Aid flow from UN agencies (US$) of Jordan in 2008?
Your answer should be very brief. 2.73e+08. What is the difference between the Aid flow from UN agencies (US$) in Fragile and conflict affected situations in 2007 and the Aid flow from UN agencies (US$) in Middle East & North Africa (all income levels) in 2008?
Ensure brevity in your answer.  -2.36e+08. What is the difference between the Aid flow from UN agencies (US$) in Fragile and conflict affected situations in 2007 and the Aid flow from UN agencies (US$) in Jordan in 2008?
Make the answer very short. 1.22e+08. What is the difference between the Aid flow from UN agencies (US$) in Middle East & North Africa (all income levels) in 2007 and the Aid flow from UN agencies (US$) in Jordan in 2008?
Make the answer very short. 2.73e+08. What is the difference between the Aid flow from UN agencies (US$) of Arab World in 2007 and the Aid flow from UN agencies (US$) of Fragile and conflict affected situations in 2009?
Your answer should be very brief. 1.01e+08. What is the difference between the Aid flow from UN agencies (US$) of Arab World in 2007 and the Aid flow from UN agencies (US$) of Middle East & North Africa (all income levels) in 2009?
Offer a very short reply. -8.44e+07. What is the difference between the Aid flow from UN agencies (US$) of Arab World in 2007 and the Aid flow from UN agencies (US$) of Jordan in 2009?
Keep it short and to the point. 2.70e+08. What is the difference between the Aid flow from UN agencies (US$) in Fragile and conflict affected situations in 2007 and the Aid flow from UN agencies (US$) in Middle East & North Africa (all income levels) in 2009?
Your response must be concise. -2.35e+08. What is the difference between the Aid flow from UN agencies (US$) in Fragile and conflict affected situations in 2007 and the Aid flow from UN agencies (US$) in Jordan in 2009?
Your answer should be compact. 1.20e+08. What is the difference between the Aid flow from UN agencies (US$) of Middle East & North Africa (all income levels) in 2007 and the Aid flow from UN agencies (US$) of Jordan in 2009?
Provide a short and direct response. 2.70e+08. What is the difference between the Aid flow from UN agencies (US$) in Arab World in 2007 and the Aid flow from UN agencies (US$) in Fragile and conflict affected situations in 2010?
Your answer should be compact. 4.74e+07. What is the difference between the Aid flow from UN agencies (US$) of Arab World in 2007 and the Aid flow from UN agencies (US$) of Middle East & North Africa (all income levels) in 2010?
Ensure brevity in your answer.  -1.57e+08. What is the difference between the Aid flow from UN agencies (US$) in Arab World in 2007 and the Aid flow from UN agencies (US$) in Jordan in 2010?
Offer a very short reply. 2.56e+08. What is the difference between the Aid flow from UN agencies (US$) of Fragile and conflict affected situations in 2007 and the Aid flow from UN agencies (US$) of Middle East & North Africa (all income levels) in 2010?
Make the answer very short. -3.07e+08. What is the difference between the Aid flow from UN agencies (US$) of Fragile and conflict affected situations in 2007 and the Aid flow from UN agencies (US$) of Jordan in 2010?
Make the answer very short. 1.05e+08. What is the difference between the Aid flow from UN agencies (US$) in Middle East & North Africa (all income levels) in 2007 and the Aid flow from UN agencies (US$) in Jordan in 2010?
Give a very brief answer. 2.56e+08. What is the difference between the Aid flow from UN agencies (US$) in Arab World in 2007 and the Aid flow from UN agencies (US$) in Fragile and conflict affected situations in 2011?
Offer a very short reply. -8.65e+06. What is the difference between the Aid flow from UN agencies (US$) in Arab World in 2007 and the Aid flow from UN agencies (US$) in Middle East & North Africa (all income levels) in 2011?
Provide a short and direct response. -2.20e+08. What is the difference between the Aid flow from UN agencies (US$) of Arab World in 2007 and the Aid flow from UN agencies (US$) of Jordan in 2011?
Give a very brief answer. 2.54e+08. What is the difference between the Aid flow from UN agencies (US$) in Fragile and conflict affected situations in 2007 and the Aid flow from UN agencies (US$) in Middle East & North Africa (all income levels) in 2011?
Provide a short and direct response. -3.70e+08. What is the difference between the Aid flow from UN agencies (US$) of Fragile and conflict affected situations in 2007 and the Aid flow from UN agencies (US$) of Jordan in 2011?
Offer a terse response. 1.03e+08. What is the difference between the Aid flow from UN agencies (US$) of Middle East & North Africa (all income levels) in 2007 and the Aid flow from UN agencies (US$) of Jordan in 2011?
Provide a succinct answer. 2.54e+08. What is the difference between the Aid flow from UN agencies (US$) in Arab World in 2008 and the Aid flow from UN agencies (US$) in Fragile and conflict affected situations in 2009?
Give a very brief answer. 1.85e+08. What is the difference between the Aid flow from UN agencies (US$) of Arab World in 2008 and the Aid flow from UN agencies (US$) of Middle East & North Africa (all income levels) in 2009?
Your answer should be very brief. 3.60e+05. What is the difference between the Aid flow from UN agencies (US$) in Arab World in 2008 and the Aid flow from UN agencies (US$) in Jordan in 2009?
Your response must be concise. 3.55e+08. What is the difference between the Aid flow from UN agencies (US$) of Fragile and conflict affected situations in 2008 and the Aid flow from UN agencies (US$) of Middle East & North Africa (all income levels) in 2009?
Offer a very short reply. -1.76e+08. What is the difference between the Aid flow from UN agencies (US$) of Fragile and conflict affected situations in 2008 and the Aid flow from UN agencies (US$) of Jordan in 2009?
Your answer should be very brief. 1.79e+08. What is the difference between the Aid flow from UN agencies (US$) of Middle East & North Africa (all income levels) in 2008 and the Aid flow from UN agencies (US$) of Jordan in 2009?
Provide a short and direct response. 3.55e+08. What is the difference between the Aid flow from UN agencies (US$) in Arab World in 2008 and the Aid flow from UN agencies (US$) in Fragile and conflict affected situations in 2010?
Provide a succinct answer. 1.32e+08. What is the difference between the Aid flow from UN agencies (US$) of Arab World in 2008 and the Aid flow from UN agencies (US$) of Middle East & North Africa (all income levels) in 2010?
Make the answer very short. -7.18e+07. What is the difference between the Aid flow from UN agencies (US$) of Arab World in 2008 and the Aid flow from UN agencies (US$) of Jordan in 2010?
Offer a terse response. 3.40e+08. What is the difference between the Aid flow from UN agencies (US$) in Fragile and conflict affected situations in 2008 and the Aid flow from UN agencies (US$) in Middle East & North Africa (all income levels) in 2010?
Offer a very short reply. -2.48e+08. What is the difference between the Aid flow from UN agencies (US$) in Fragile and conflict affected situations in 2008 and the Aid flow from UN agencies (US$) in Jordan in 2010?
Give a very brief answer. 1.64e+08. What is the difference between the Aid flow from UN agencies (US$) in Middle East & North Africa (all income levels) in 2008 and the Aid flow from UN agencies (US$) in Jordan in 2010?
Give a very brief answer. 3.40e+08. What is the difference between the Aid flow from UN agencies (US$) in Arab World in 2008 and the Aid flow from UN agencies (US$) in Fragile and conflict affected situations in 2011?
Provide a short and direct response. 7.61e+07. What is the difference between the Aid flow from UN agencies (US$) in Arab World in 2008 and the Aid flow from UN agencies (US$) in Middle East & North Africa (all income levels) in 2011?
Your answer should be very brief. -1.35e+08. What is the difference between the Aid flow from UN agencies (US$) in Arab World in 2008 and the Aid flow from UN agencies (US$) in Jordan in 2011?
Your response must be concise. 3.39e+08. What is the difference between the Aid flow from UN agencies (US$) of Fragile and conflict affected situations in 2008 and the Aid flow from UN agencies (US$) of Middle East & North Africa (all income levels) in 2011?
Ensure brevity in your answer.  -3.11e+08. What is the difference between the Aid flow from UN agencies (US$) of Fragile and conflict affected situations in 2008 and the Aid flow from UN agencies (US$) of Jordan in 2011?
Your answer should be very brief. 1.63e+08. What is the difference between the Aid flow from UN agencies (US$) of Middle East & North Africa (all income levels) in 2008 and the Aid flow from UN agencies (US$) of Jordan in 2011?
Your response must be concise. 3.39e+08. What is the difference between the Aid flow from UN agencies (US$) of Arab World in 2009 and the Aid flow from UN agencies (US$) of Fragile and conflict affected situations in 2010?
Keep it short and to the point. 1.32e+08. What is the difference between the Aid flow from UN agencies (US$) in Arab World in 2009 and the Aid flow from UN agencies (US$) in Middle East & North Africa (all income levels) in 2010?
Your answer should be compact. -7.21e+07. What is the difference between the Aid flow from UN agencies (US$) of Arab World in 2009 and the Aid flow from UN agencies (US$) of Jordan in 2010?
Provide a short and direct response. 3.40e+08. What is the difference between the Aid flow from UN agencies (US$) in Fragile and conflict affected situations in 2009 and the Aid flow from UN agencies (US$) in Middle East & North Africa (all income levels) in 2010?
Your response must be concise. -2.57e+08. What is the difference between the Aid flow from UN agencies (US$) in Fragile and conflict affected situations in 2009 and the Aid flow from UN agencies (US$) in Jordan in 2010?
Your answer should be very brief. 1.55e+08. What is the difference between the Aid flow from UN agencies (US$) of Middle East & North Africa (all income levels) in 2009 and the Aid flow from UN agencies (US$) of Jordan in 2010?
Your response must be concise. 3.40e+08. What is the difference between the Aid flow from UN agencies (US$) in Arab World in 2009 and the Aid flow from UN agencies (US$) in Fragile and conflict affected situations in 2011?
Offer a terse response. 7.57e+07. What is the difference between the Aid flow from UN agencies (US$) in Arab World in 2009 and the Aid flow from UN agencies (US$) in Middle East & North Africa (all income levels) in 2011?
Your answer should be very brief. -1.35e+08. What is the difference between the Aid flow from UN agencies (US$) of Arab World in 2009 and the Aid flow from UN agencies (US$) of Jordan in 2011?
Your answer should be very brief. 3.39e+08. What is the difference between the Aid flow from UN agencies (US$) in Fragile and conflict affected situations in 2009 and the Aid flow from UN agencies (US$) in Middle East & North Africa (all income levels) in 2011?
Your answer should be very brief. -3.20e+08. What is the difference between the Aid flow from UN agencies (US$) in Fragile and conflict affected situations in 2009 and the Aid flow from UN agencies (US$) in Jordan in 2011?
Ensure brevity in your answer.  1.54e+08. What is the difference between the Aid flow from UN agencies (US$) of Middle East & North Africa (all income levels) in 2009 and the Aid flow from UN agencies (US$) of Jordan in 2011?
Your answer should be very brief. 3.39e+08. What is the difference between the Aid flow from UN agencies (US$) of Arab World in 2010 and the Aid flow from UN agencies (US$) of Fragile and conflict affected situations in 2011?
Make the answer very short. 1.48e+08. What is the difference between the Aid flow from UN agencies (US$) of Arab World in 2010 and the Aid flow from UN agencies (US$) of Middle East & North Africa (all income levels) in 2011?
Give a very brief answer. -6.30e+07. What is the difference between the Aid flow from UN agencies (US$) of Arab World in 2010 and the Aid flow from UN agencies (US$) of Jordan in 2011?
Ensure brevity in your answer.  4.11e+08. What is the difference between the Aid flow from UN agencies (US$) in Fragile and conflict affected situations in 2010 and the Aid flow from UN agencies (US$) in Middle East & North Africa (all income levels) in 2011?
Your response must be concise. -2.67e+08. What is the difference between the Aid flow from UN agencies (US$) of Fragile and conflict affected situations in 2010 and the Aid flow from UN agencies (US$) of Jordan in 2011?
Ensure brevity in your answer.  2.07e+08. What is the difference between the Aid flow from UN agencies (US$) of Middle East & North Africa (all income levels) in 2010 and the Aid flow from UN agencies (US$) of Jordan in 2011?
Make the answer very short. 4.11e+08. What is the average Aid flow from UN agencies (US$) of Arab World per year?
Provide a short and direct response. 4.57e+08. What is the average Aid flow from UN agencies (US$) in Fragile and conflict affected situations per year?
Ensure brevity in your answer.  2.87e+08. What is the average Aid flow from UN agencies (US$) in Middle East & North Africa (all income levels) per year?
Provide a succinct answer. 4.57e+08. What is the average Aid flow from UN agencies (US$) of Jordan per year?
Give a very brief answer. 1.09e+08. In the year 2004, what is the difference between the Aid flow from UN agencies (US$) of Arab World and Aid flow from UN agencies (US$) of Fragile and conflict affected situations?
Provide a succinct answer. 1.47e+08. In the year 2004, what is the difference between the Aid flow from UN agencies (US$) in Arab World and Aid flow from UN agencies (US$) in Middle East & North Africa (all income levels)?
Provide a succinct answer. 0. In the year 2004, what is the difference between the Aid flow from UN agencies (US$) in Arab World and Aid flow from UN agencies (US$) in Jordan?
Give a very brief answer. 3.59e+08. In the year 2004, what is the difference between the Aid flow from UN agencies (US$) in Fragile and conflict affected situations and Aid flow from UN agencies (US$) in Middle East & North Africa (all income levels)?
Make the answer very short. -1.47e+08. In the year 2004, what is the difference between the Aid flow from UN agencies (US$) of Fragile and conflict affected situations and Aid flow from UN agencies (US$) of Jordan?
Offer a very short reply. 2.12e+08. In the year 2004, what is the difference between the Aid flow from UN agencies (US$) of Middle East & North Africa (all income levels) and Aid flow from UN agencies (US$) of Jordan?
Provide a short and direct response. 3.59e+08. In the year 2005, what is the difference between the Aid flow from UN agencies (US$) in Arab World and Aid flow from UN agencies (US$) in Fragile and conflict affected situations?
Ensure brevity in your answer.  1.44e+08. In the year 2005, what is the difference between the Aid flow from UN agencies (US$) in Arab World and Aid flow from UN agencies (US$) in Jordan?
Offer a terse response. 2.58e+08. In the year 2005, what is the difference between the Aid flow from UN agencies (US$) in Fragile and conflict affected situations and Aid flow from UN agencies (US$) in Middle East & North Africa (all income levels)?
Provide a short and direct response. -1.44e+08. In the year 2005, what is the difference between the Aid flow from UN agencies (US$) of Fragile and conflict affected situations and Aid flow from UN agencies (US$) of Jordan?
Keep it short and to the point. 1.14e+08. In the year 2005, what is the difference between the Aid flow from UN agencies (US$) of Middle East & North Africa (all income levels) and Aid flow from UN agencies (US$) of Jordan?
Make the answer very short. 2.58e+08. In the year 2006, what is the difference between the Aid flow from UN agencies (US$) of Arab World and Aid flow from UN agencies (US$) of Fragile and conflict affected situations?
Provide a short and direct response. 1.43e+08. In the year 2006, what is the difference between the Aid flow from UN agencies (US$) of Arab World and Aid flow from UN agencies (US$) of Middle East & North Africa (all income levels)?
Your answer should be very brief. 0. In the year 2006, what is the difference between the Aid flow from UN agencies (US$) in Arab World and Aid flow from UN agencies (US$) in Jordan?
Provide a succinct answer. 2.80e+08. In the year 2006, what is the difference between the Aid flow from UN agencies (US$) of Fragile and conflict affected situations and Aid flow from UN agencies (US$) of Middle East & North Africa (all income levels)?
Provide a succinct answer. -1.43e+08. In the year 2006, what is the difference between the Aid flow from UN agencies (US$) in Fragile and conflict affected situations and Aid flow from UN agencies (US$) in Jordan?
Offer a terse response. 1.37e+08. In the year 2006, what is the difference between the Aid flow from UN agencies (US$) in Middle East & North Africa (all income levels) and Aid flow from UN agencies (US$) in Jordan?
Provide a succinct answer. 2.80e+08. In the year 2007, what is the difference between the Aid flow from UN agencies (US$) in Arab World and Aid flow from UN agencies (US$) in Fragile and conflict affected situations?
Ensure brevity in your answer.  1.51e+08. In the year 2007, what is the difference between the Aid flow from UN agencies (US$) of Arab World and Aid flow from UN agencies (US$) of Middle East & North Africa (all income levels)?
Your answer should be very brief. 0. In the year 2007, what is the difference between the Aid flow from UN agencies (US$) in Arab World and Aid flow from UN agencies (US$) in Jordan?
Provide a short and direct response. 2.90e+08. In the year 2007, what is the difference between the Aid flow from UN agencies (US$) in Fragile and conflict affected situations and Aid flow from UN agencies (US$) in Middle East & North Africa (all income levels)?
Give a very brief answer. -1.51e+08. In the year 2007, what is the difference between the Aid flow from UN agencies (US$) in Fragile and conflict affected situations and Aid flow from UN agencies (US$) in Jordan?
Provide a short and direct response. 1.39e+08. In the year 2007, what is the difference between the Aid flow from UN agencies (US$) in Middle East & North Africa (all income levels) and Aid flow from UN agencies (US$) in Jordan?
Provide a short and direct response. 2.90e+08. In the year 2008, what is the difference between the Aid flow from UN agencies (US$) in Arab World and Aid flow from UN agencies (US$) in Fragile and conflict affected situations?
Offer a terse response. 1.76e+08. In the year 2008, what is the difference between the Aid flow from UN agencies (US$) in Arab World and Aid flow from UN agencies (US$) in Middle East & North Africa (all income levels)?
Offer a terse response. 0. In the year 2008, what is the difference between the Aid flow from UN agencies (US$) in Arab World and Aid flow from UN agencies (US$) in Jordan?
Make the answer very short. 3.58e+08. In the year 2008, what is the difference between the Aid flow from UN agencies (US$) in Fragile and conflict affected situations and Aid flow from UN agencies (US$) in Middle East & North Africa (all income levels)?
Give a very brief answer. -1.76e+08. In the year 2008, what is the difference between the Aid flow from UN agencies (US$) in Fragile and conflict affected situations and Aid flow from UN agencies (US$) in Jordan?
Keep it short and to the point. 1.81e+08. In the year 2008, what is the difference between the Aid flow from UN agencies (US$) of Middle East & North Africa (all income levels) and Aid flow from UN agencies (US$) of Jordan?
Keep it short and to the point. 3.58e+08. In the year 2009, what is the difference between the Aid flow from UN agencies (US$) of Arab World and Aid flow from UN agencies (US$) of Fragile and conflict affected situations?
Provide a short and direct response. 1.85e+08. In the year 2009, what is the difference between the Aid flow from UN agencies (US$) of Arab World and Aid flow from UN agencies (US$) of Middle East & North Africa (all income levels)?
Provide a short and direct response. 0. In the year 2009, what is the difference between the Aid flow from UN agencies (US$) in Arab World and Aid flow from UN agencies (US$) in Jordan?
Provide a succinct answer. 3.55e+08. In the year 2009, what is the difference between the Aid flow from UN agencies (US$) in Fragile and conflict affected situations and Aid flow from UN agencies (US$) in Middle East & North Africa (all income levels)?
Keep it short and to the point. -1.85e+08. In the year 2009, what is the difference between the Aid flow from UN agencies (US$) of Fragile and conflict affected situations and Aid flow from UN agencies (US$) of Jordan?
Offer a very short reply. 1.70e+08. In the year 2009, what is the difference between the Aid flow from UN agencies (US$) in Middle East & North Africa (all income levels) and Aid flow from UN agencies (US$) in Jordan?
Make the answer very short. 3.55e+08. In the year 2010, what is the difference between the Aid flow from UN agencies (US$) in Arab World and Aid flow from UN agencies (US$) in Fragile and conflict affected situations?
Provide a short and direct response. 2.04e+08. In the year 2010, what is the difference between the Aid flow from UN agencies (US$) in Arab World and Aid flow from UN agencies (US$) in Middle East & North Africa (all income levels)?
Offer a very short reply. 0. In the year 2010, what is the difference between the Aid flow from UN agencies (US$) of Arab World and Aid flow from UN agencies (US$) of Jordan?
Offer a terse response. 4.12e+08. In the year 2010, what is the difference between the Aid flow from UN agencies (US$) in Fragile and conflict affected situations and Aid flow from UN agencies (US$) in Middle East & North Africa (all income levels)?
Make the answer very short. -2.04e+08. In the year 2010, what is the difference between the Aid flow from UN agencies (US$) in Fragile and conflict affected situations and Aid flow from UN agencies (US$) in Jordan?
Offer a terse response. 2.08e+08. In the year 2010, what is the difference between the Aid flow from UN agencies (US$) in Middle East & North Africa (all income levels) and Aid flow from UN agencies (US$) in Jordan?
Your response must be concise. 4.12e+08. In the year 2011, what is the difference between the Aid flow from UN agencies (US$) of Arab World and Aid flow from UN agencies (US$) of Fragile and conflict affected situations?
Give a very brief answer. 2.11e+08. In the year 2011, what is the difference between the Aid flow from UN agencies (US$) of Arab World and Aid flow from UN agencies (US$) of Jordan?
Keep it short and to the point. 4.74e+08. In the year 2011, what is the difference between the Aid flow from UN agencies (US$) of Fragile and conflict affected situations and Aid flow from UN agencies (US$) of Middle East & North Africa (all income levels)?
Provide a succinct answer. -2.11e+08. In the year 2011, what is the difference between the Aid flow from UN agencies (US$) of Fragile and conflict affected situations and Aid flow from UN agencies (US$) of Jordan?
Your answer should be very brief. 2.63e+08. In the year 2011, what is the difference between the Aid flow from UN agencies (US$) of Middle East & North Africa (all income levels) and Aid flow from UN agencies (US$) of Jordan?
Provide a succinct answer. 4.74e+08. What is the ratio of the Aid flow from UN agencies (US$) of Arab World in 2004 to that in 2005?
Make the answer very short. 1.28. What is the ratio of the Aid flow from UN agencies (US$) of Fragile and conflict affected situations in 2004 to that in 2005?
Offer a very short reply. 1.46. What is the ratio of the Aid flow from UN agencies (US$) in Middle East & North Africa (all income levels) in 2004 to that in 2005?
Offer a terse response. 1.28. What is the ratio of the Aid flow from UN agencies (US$) of Jordan in 2004 to that in 2005?
Your answer should be compact. 0.97. What is the ratio of the Aid flow from UN agencies (US$) in Arab World in 2004 to that in 2006?
Provide a short and direct response. 1.21. What is the ratio of the Aid flow from UN agencies (US$) of Fragile and conflict affected situations in 2004 to that in 2006?
Offer a terse response. 1.32. What is the ratio of the Aid flow from UN agencies (US$) of Middle East & North Africa (all income levels) in 2004 to that in 2006?
Offer a terse response. 1.21. What is the ratio of the Aid flow from UN agencies (US$) of Jordan in 2004 to that in 2006?
Provide a short and direct response. 0.98. What is the ratio of the Aid flow from UN agencies (US$) in Arab World in 2004 to that in 2007?
Keep it short and to the point. 1.16. What is the ratio of the Aid flow from UN agencies (US$) of Fragile and conflict affected situations in 2004 to that in 2007?
Your answer should be very brief. 1.27. What is the ratio of the Aid flow from UN agencies (US$) in Middle East & North Africa (all income levels) in 2004 to that in 2007?
Provide a succinct answer. 1.16. What is the ratio of the Aid flow from UN agencies (US$) of Jordan in 2004 to that in 2007?
Your answer should be compact. 0.91. What is the ratio of the Aid flow from UN agencies (US$) of Arab World in 2004 to that in 2008?
Keep it short and to the point. 0.95. What is the ratio of the Aid flow from UN agencies (US$) in Fragile and conflict affected situations in 2004 to that in 2008?
Offer a very short reply. 1.02. What is the ratio of the Aid flow from UN agencies (US$) of Middle East & North Africa (all income levels) in 2004 to that in 2008?
Offer a terse response. 0.95. What is the ratio of the Aid flow from UN agencies (US$) in Jordan in 2004 to that in 2008?
Give a very brief answer. 0.78. What is the ratio of the Aid flow from UN agencies (US$) in Arab World in 2004 to that in 2009?
Make the answer very short. 0.95. What is the ratio of the Aid flow from UN agencies (US$) in Fragile and conflict affected situations in 2004 to that in 2009?
Provide a succinct answer. 1.05. What is the ratio of the Aid flow from UN agencies (US$) of Middle East & North Africa (all income levels) in 2004 to that in 2009?
Offer a very short reply. 0.95. What is the ratio of the Aid flow from UN agencies (US$) in Jordan in 2004 to that in 2009?
Your response must be concise. 0.76. What is the ratio of the Aid flow from UN agencies (US$) in Arab World in 2004 to that in 2010?
Your answer should be compact. 0.82. What is the ratio of the Aid flow from UN agencies (US$) in Fragile and conflict affected situations in 2004 to that in 2010?
Make the answer very short. 0.88. What is the ratio of the Aid flow from UN agencies (US$) in Middle East & North Africa (all income levels) in 2004 to that in 2010?
Keep it short and to the point. 0.82. What is the ratio of the Aid flow from UN agencies (US$) of Jordan in 2004 to that in 2010?
Provide a short and direct response. 0.67. What is the ratio of the Aid flow from UN agencies (US$) in Arab World in 2004 to that in 2011?
Your answer should be very brief. 0.74. What is the ratio of the Aid flow from UN agencies (US$) in Fragile and conflict affected situations in 2004 to that in 2011?
Offer a terse response. 0.76. What is the ratio of the Aid flow from UN agencies (US$) of Middle East & North Africa (all income levels) in 2004 to that in 2011?
Make the answer very short. 0.74. What is the ratio of the Aid flow from UN agencies (US$) in Jordan in 2004 to that in 2011?
Make the answer very short. 0.67. What is the ratio of the Aid flow from UN agencies (US$) in Arab World in 2005 to that in 2006?
Keep it short and to the point. 0.94. What is the ratio of the Aid flow from UN agencies (US$) in Fragile and conflict affected situations in 2005 to that in 2006?
Provide a short and direct response. 0.9. What is the ratio of the Aid flow from UN agencies (US$) of Middle East & North Africa (all income levels) in 2005 to that in 2006?
Your response must be concise. 0.94. What is the ratio of the Aid flow from UN agencies (US$) in Jordan in 2005 to that in 2006?
Your answer should be very brief. 1.01. What is the ratio of the Aid flow from UN agencies (US$) in Arab World in 2005 to that in 2007?
Your answer should be very brief. 0.9. What is the ratio of the Aid flow from UN agencies (US$) in Fragile and conflict affected situations in 2005 to that in 2007?
Your answer should be very brief. 0.87. What is the ratio of the Aid flow from UN agencies (US$) of Middle East & North Africa (all income levels) in 2005 to that in 2007?
Offer a very short reply. 0.9. What is the ratio of the Aid flow from UN agencies (US$) in Jordan in 2005 to that in 2007?
Give a very brief answer. 0.93. What is the ratio of the Aid flow from UN agencies (US$) of Arab World in 2005 to that in 2008?
Your answer should be compact. 0.74. What is the ratio of the Aid flow from UN agencies (US$) in Fragile and conflict affected situations in 2005 to that in 2008?
Offer a terse response. 0.7. What is the ratio of the Aid flow from UN agencies (US$) of Middle East & North Africa (all income levels) in 2005 to that in 2008?
Keep it short and to the point. 0.74. What is the ratio of the Aid flow from UN agencies (US$) in Jordan in 2005 to that in 2008?
Ensure brevity in your answer.  0.8. What is the ratio of the Aid flow from UN agencies (US$) of Arab World in 2005 to that in 2009?
Keep it short and to the point. 0.74. What is the ratio of the Aid flow from UN agencies (US$) in Fragile and conflict affected situations in 2005 to that in 2009?
Provide a short and direct response. 0.72. What is the ratio of the Aid flow from UN agencies (US$) in Middle East & North Africa (all income levels) in 2005 to that in 2009?
Your answer should be compact. 0.74. What is the ratio of the Aid flow from UN agencies (US$) in Jordan in 2005 to that in 2009?
Your answer should be very brief. 0.78. What is the ratio of the Aid flow from UN agencies (US$) of Arab World in 2005 to that in 2010?
Give a very brief answer. 0.64. What is the ratio of the Aid flow from UN agencies (US$) of Fragile and conflict affected situations in 2005 to that in 2010?
Your response must be concise. 0.61. What is the ratio of the Aid flow from UN agencies (US$) in Middle East & North Africa (all income levels) in 2005 to that in 2010?
Your response must be concise. 0.64. What is the ratio of the Aid flow from UN agencies (US$) of Jordan in 2005 to that in 2010?
Give a very brief answer. 0.69. What is the ratio of the Aid flow from UN agencies (US$) of Arab World in 2005 to that in 2011?
Your response must be concise. 0.58. What is the ratio of the Aid flow from UN agencies (US$) of Fragile and conflict affected situations in 2005 to that in 2011?
Your answer should be compact. 0.52. What is the ratio of the Aid flow from UN agencies (US$) of Middle East & North Africa (all income levels) in 2005 to that in 2011?
Make the answer very short. 0.58. What is the ratio of the Aid flow from UN agencies (US$) in Jordan in 2005 to that in 2011?
Offer a very short reply. 0.69. What is the ratio of the Aid flow from UN agencies (US$) of Arab World in 2006 to that in 2007?
Provide a succinct answer. 0.96. What is the ratio of the Aid flow from UN agencies (US$) in Fragile and conflict affected situations in 2006 to that in 2007?
Offer a terse response. 0.96. What is the ratio of the Aid flow from UN agencies (US$) in Middle East & North Africa (all income levels) in 2006 to that in 2007?
Make the answer very short. 0.96. What is the ratio of the Aid flow from UN agencies (US$) of Jordan in 2006 to that in 2007?
Give a very brief answer. 0.93. What is the ratio of the Aid flow from UN agencies (US$) in Arab World in 2006 to that in 2008?
Keep it short and to the point. 0.79. What is the ratio of the Aid flow from UN agencies (US$) of Fragile and conflict affected situations in 2006 to that in 2008?
Give a very brief answer. 0.77. What is the ratio of the Aid flow from UN agencies (US$) of Middle East & North Africa (all income levels) in 2006 to that in 2008?
Your answer should be very brief. 0.79. What is the ratio of the Aid flow from UN agencies (US$) in Jordan in 2006 to that in 2008?
Offer a terse response. 0.79. What is the ratio of the Aid flow from UN agencies (US$) of Arab World in 2006 to that in 2009?
Provide a succinct answer. 0.79. What is the ratio of the Aid flow from UN agencies (US$) of Fragile and conflict affected situations in 2006 to that in 2009?
Provide a short and direct response. 0.8. What is the ratio of the Aid flow from UN agencies (US$) in Middle East & North Africa (all income levels) in 2006 to that in 2009?
Ensure brevity in your answer.  0.79. What is the ratio of the Aid flow from UN agencies (US$) in Jordan in 2006 to that in 2009?
Give a very brief answer. 0.78. What is the ratio of the Aid flow from UN agencies (US$) of Arab World in 2006 to that in 2010?
Offer a very short reply. 0.68. What is the ratio of the Aid flow from UN agencies (US$) in Fragile and conflict affected situations in 2006 to that in 2010?
Your response must be concise. 0.67. What is the ratio of the Aid flow from UN agencies (US$) in Middle East & North Africa (all income levels) in 2006 to that in 2010?
Give a very brief answer. 0.68. What is the ratio of the Aid flow from UN agencies (US$) of Jordan in 2006 to that in 2010?
Your answer should be compact. 0.69. What is the ratio of the Aid flow from UN agencies (US$) in Arab World in 2006 to that in 2011?
Your answer should be compact. 0.61. What is the ratio of the Aid flow from UN agencies (US$) in Fragile and conflict affected situations in 2006 to that in 2011?
Keep it short and to the point. 0.58. What is the ratio of the Aid flow from UN agencies (US$) in Middle East & North Africa (all income levels) in 2006 to that in 2011?
Offer a terse response. 0.61. What is the ratio of the Aid flow from UN agencies (US$) of Jordan in 2006 to that in 2011?
Ensure brevity in your answer.  0.68. What is the ratio of the Aid flow from UN agencies (US$) in Arab World in 2007 to that in 2008?
Provide a succinct answer. 0.82. What is the ratio of the Aid flow from UN agencies (US$) in Fragile and conflict affected situations in 2007 to that in 2008?
Provide a short and direct response. 0.8. What is the ratio of the Aid flow from UN agencies (US$) in Middle East & North Africa (all income levels) in 2007 to that in 2008?
Keep it short and to the point. 0.82. What is the ratio of the Aid flow from UN agencies (US$) of Jordan in 2007 to that in 2008?
Offer a very short reply. 0.86. What is the ratio of the Aid flow from UN agencies (US$) in Arab World in 2007 to that in 2009?
Give a very brief answer. 0.82. What is the ratio of the Aid flow from UN agencies (US$) in Fragile and conflict affected situations in 2007 to that in 2009?
Provide a short and direct response. 0.83. What is the ratio of the Aid flow from UN agencies (US$) of Middle East & North Africa (all income levels) in 2007 to that in 2009?
Keep it short and to the point. 0.82. What is the ratio of the Aid flow from UN agencies (US$) of Jordan in 2007 to that in 2009?
Provide a short and direct response. 0.84. What is the ratio of the Aid flow from UN agencies (US$) in Arab World in 2007 to that in 2010?
Provide a short and direct response. 0.71. What is the ratio of the Aid flow from UN agencies (US$) in Fragile and conflict affected situations in 2007 to that in 2010?
Offer a very short reply. 0.7. What is the ratio of the Aid flow from UN agencies (US$) in Middle East & North Africa (all income levels) in 2007 to that in 2010?
Your answer should be compact. 0.71. What is the ratio of the Aid flow from UN agencies (US$) in Jordan in 2007 to that in 2010?
Ensure brevity in your answer.  0.74. What is the ratio of the Aid flow from UN agencies (US$) in Arab World in 2007 to that in 2011?
Your answer should be very brief. 0.64. What is the ratio of the Aid flow from UN agencies (US$) of Fragile and conflict affected situations in 2007 to that in 2011?
Offer a terse response. 0.6. What is the ratio of the Aid flow from UN agencies (US$) in Middle East & North Africa (all income levels) in 2007 to that in 2011?
Provide a succinct answer. 0.64. What is the ratio of the Aid flow from UN agencies (US$) of Jordan in 2007 to that in 2011?
Give a very brief answer. 0.74. What is the ratio of the Aid flow from UN agencies (US$) in Fragile and conflict affected situations in 2008 to that in 2009?
Provide a succinct answer. 1.03. What is the ratio of the Aid flow from UN agencies (US$) of Jordan in 2008 to that in 2009?
Your answer should be very brief. 0.98. What is the ratio of the Aid flow from UN agencies (US$) in Arab World in 2008 to that in 2010?
Your answer should be compact. 0.87. What is the ratio of the Aid flow from UN agencies (US$) of Fragile and conflict affected situations in 2008 to that in 2010?
Make the answer very short. 0.87. What is the ratio of the Aid flow from UN agencies (US$) in Middle East & North Africa (all income levels) in 2008 to that in 2010?
Provide a short and direct response. 0.87. What is the ratio of the Aid flow from UN agencies (US$) in Jordan in 2008 to that in 2010?
Offer a very short reply. 0.87. What is the ratio of the Aid flow from UN agencies (US$) of Arab World in 2008 to that in 2011?
Give a very brief answer. 0.78. What is the ratio of the Aid flow from UN agencies (US$) of Fragile and conflict affected situations in 2008 to that in 2011?
Your answer should be very brief. 0.75. What is the ratio of the Aid flow from UN agencies (US$) of Middle East & North Africa (all income levels) in 2008 to that in 2011?
Offer a very short reply. 0.78. What is the ratio of the Aid flow from UN agencies (US$) in Jordan in 2008 to that in 2011?
Your answer should be very brief. 0.86. What is the ratio of the Aid flow from UN agencies (US$) in Arab World in 2009 to that in 2010?
Your answer should be very brief. 0.87. What is the ratio of the Aid flow from UN agencies (US$) of Fragile and conflict affected situations in 2009 to that in 2010?
Make the answer very short. 0.84. What is the ratio of the Aid flow from UN agencies (US$) in Middle East & North Africa (all income levels) in 2009 to that in 2010?
Give a very brief answer. 0.87. What is the ratio of the Aid flow from UN agencies (US$) in Jordan in 2009 to that in 2010?
Give a very brief answer. 0.89. What is the ratio of the Aid flow from UN agencies (US$) of Fragile and conflict affected situations in 2009 to that in 2011?
Your answer should be compact. 0.72. What is the ratio of the Aid flow from UN agencies (US$) of Jordan in 2009 to that in 2011?
Keep it short and to the point. 0.88. What is the ratio of the Aid flow from UN agencies (US$) of Arab World in 2010 to that in 2011?
Offer a terse response. 0.9. What is the ratio of the Aid flow from UN agencies (US$) of Fragile and conflict affected situations in 2010 to that in 2011?
Keep it short and to the point. 0.86. What is the ratio of the Aid flow from UN agencies (US$) of Middle East & North Africa (all income levels) in 2010 to that in 2011?
Ensure brevity in your answer.  0.9. What is the difference between the highest and the second highest Aid flow from UN agencies (US$) of Arab World?
Your answer should be compact. 6.30e+07. What is the difference between the highest and the second highest Aid flow from UN agencies (US$) in Fragile and conflict affected situations?
Ensure brevity in your answer.  5.60e+07. What is the difference between the highest and the second highest Aid flow from UN agencies (US$) of Middle East & North Africa (all income levels)?
Your answer should be very brief. 6.30e+07. What is the difference between the highest and the second highest Aid flow from UN agencies (US$) of Jordan?
Provide a short and direct response. 1.29e+06. What is the difference between the highest and the lowest Aid flow from UN agencies (US$) of Arab World?
Make the answer very short. 2.58e+08. What is the difference between the highest and the lowest Aid flow from UN agencies (US$) in Fragile and conflict affected situations?
Make the answer very short. 1.91e+08. What is the difference between the highest and the lowest Aid flow from UN agencies (US$) of Middle East & North Africa (all income levels)?
Your response must be concise. 2.58e+08. What is the difference between the highest and the lowest Aid flow from UN agencies (US$) of Jordan?
Your response must be concise. 4.46e+07. 